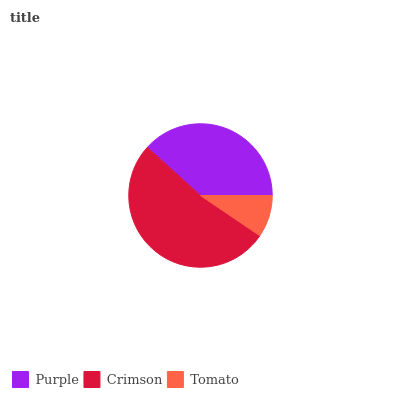Is Tomato the minimum?
Answer yes or no. Yes. Is Crimson the maximum?
Answer yes or no. Yes. Is Crimson the minimum?
Answer yes or no. No. Is Tomato the maximum?
Answer yes or no. No. Is Crimson greater than Tomato?
Answer yes or no. Yes. Is Tomato less than Crimson?
Answer yes or no. Yes. Is Tomato greater than Crimson?
Answer yes or no. No. Is Crimson less than Tomato?
Answer yes or no. No. Is Purple the high median?
Answer yes or no. Yes. Is Purple the low median?
Answer yes or no. Yes. Is Tomato the high median?
Answer yes or no. No. Is Tomato the low median?
Answer yes or no. No. 